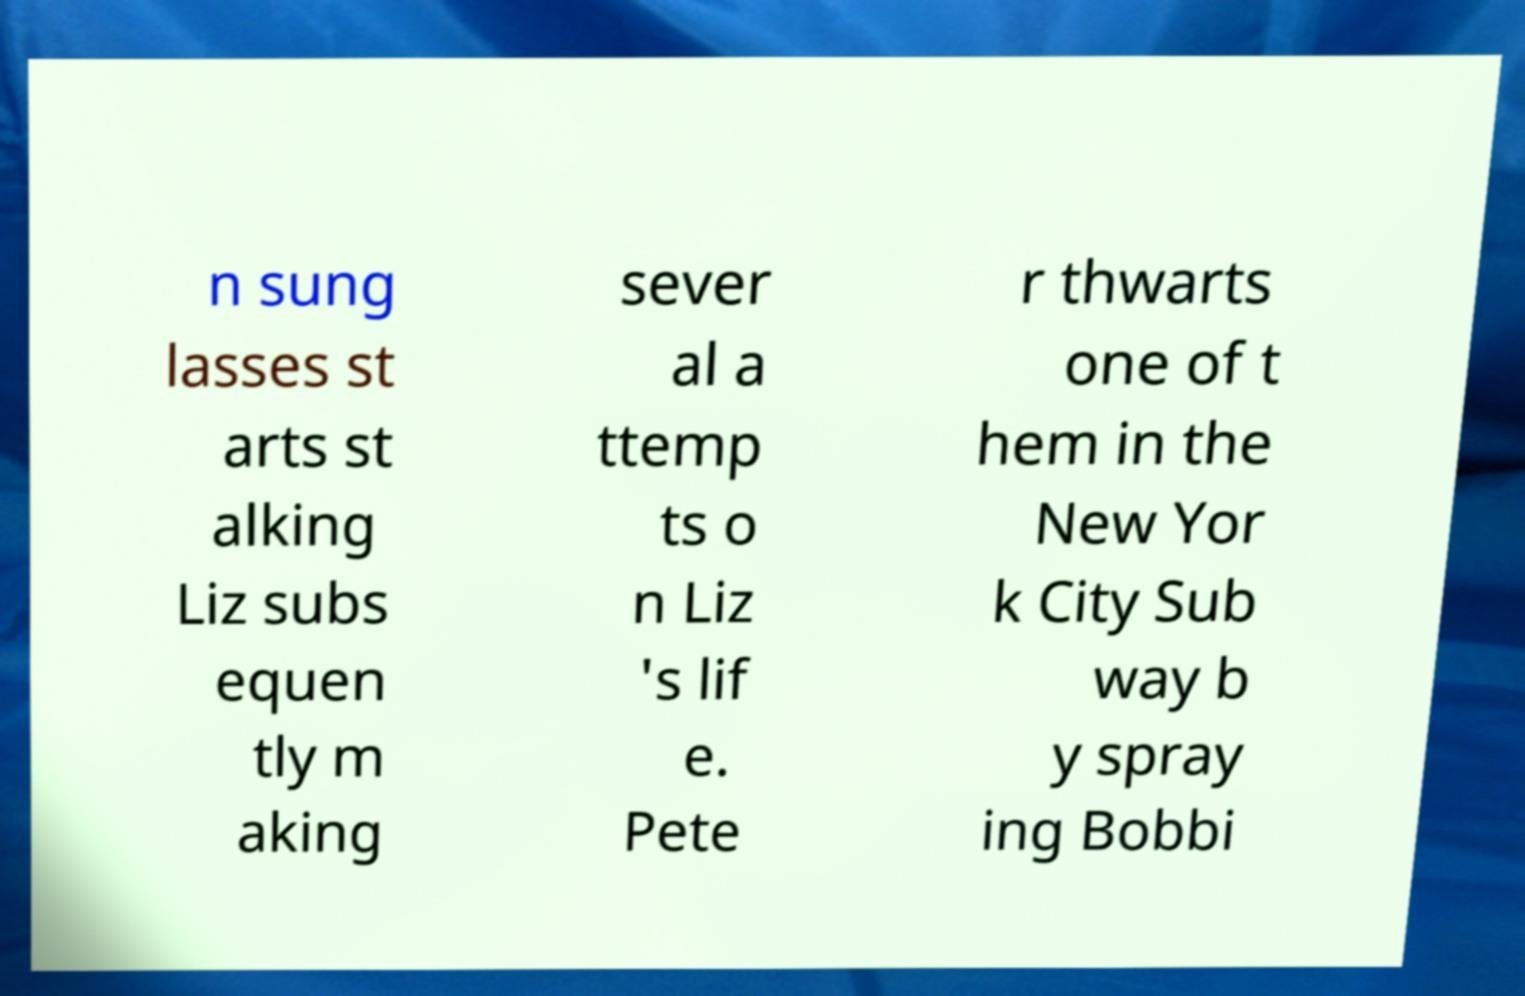What messages or text are displayed in this image? I need them in a readable, typed format. n sung lasses st arts st alking Liz subs equen tly m aking sever al a ttemp ts o n Liz 's lif e. Pete r thwarts one of t hem in the New Yor k City Sub way b y spray ing Bobbi 